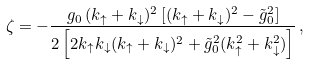<formula> <loc_0><loc_0><loc_500><loc_500>\zeta = - \frac { g _ { 0 } \, ( k _ { \uparrow } + k _ { \downarrow } ) ^ { 2 } \, [ ( k _ { \uparrow } + k _ { \downarrow } ) ^ { 2 } - \tilde { g } _ { 0 } ^ { 2 } ] } { 2 \left [ 2 k _ { \uparrow } k _ { \downarrow } ( k _ { \uparrow } + k _ { \downarrow } ) ^ { 2 } + \tilde { g } _ { 0 } ^ { 2 } ( k _ { \uparrow } ^ { 2 } + k _ { \downarrow } ^ { 2 } ) \right ] } \, ,</formula> 